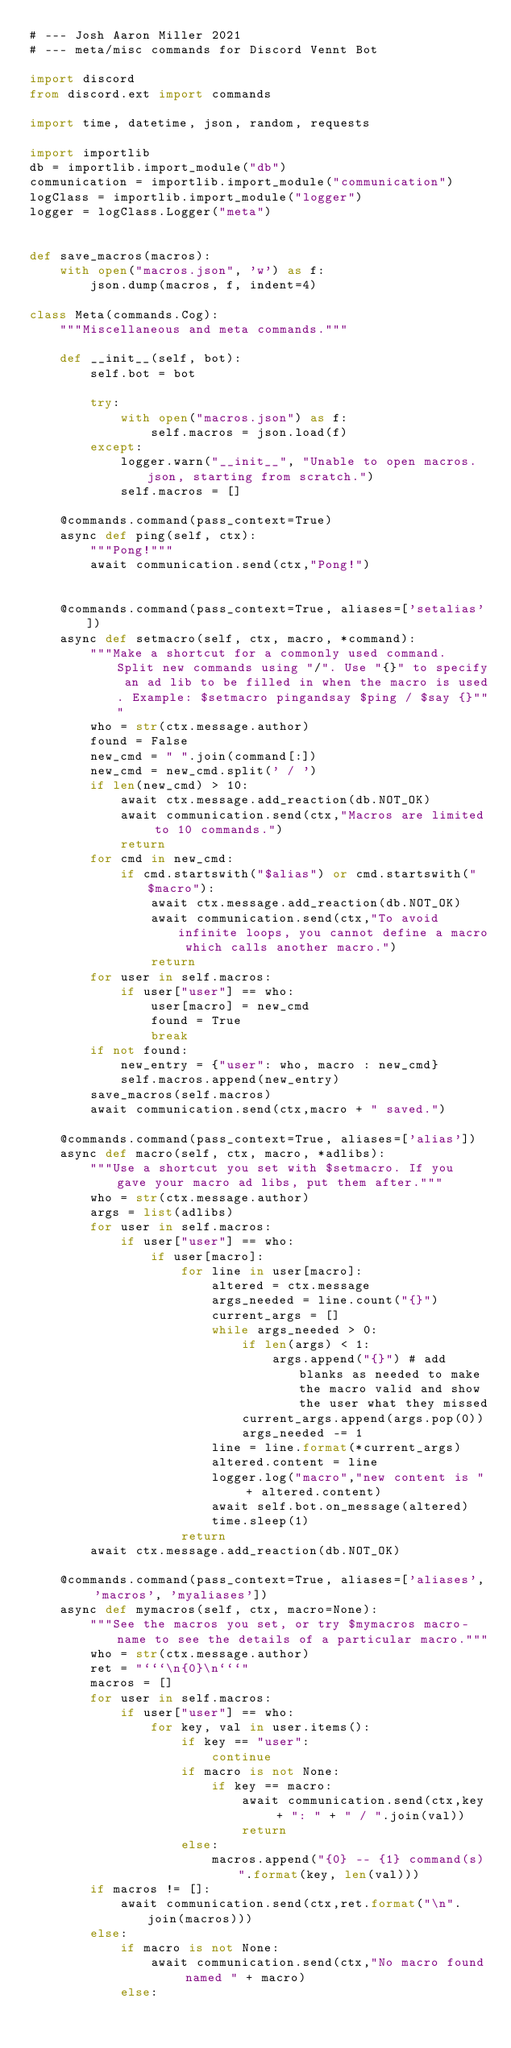Convert code to text. <code><loc_0><loc_0><loc_500><loc_500><_Python_># --- Josh Aaron Miller 2021
# --- meta/misc commands for Discord Vennt Bot

import discord
from discord.ext import commands

import time, datetime, json, random, requests

import importlib
db = importlib.import_module("db")
communication = importlib.import_module("communication")
logClass = importlib.import_module("logger")
logger = logClass.Logger("meta")

    
def save_macros(macros):
    with open("macros.json", 'w') as f:
        json.dump(macros, f, indent=4)
    
class Meta(commands.Cog):
    """Miscellaneous and meta commands."""

    def __init__(self, bot):
        self.bot = bot
           
        try:
            with open("macros.json") as f:
                self.macros = json.load(f)
        except:
            logger.warn("__init__", "Unable to open macros.json, starting from scratch.")
            self.macros = []

    @commands.command(pass_context=True)
    async def ping(self, ctx):
        """Pong!"""
        await communication.send(ctx,"Pong!")
    

    @commands.command(pass_context=True, aliases=['setalias'])
    async def setmacro(self, ctx, macro, *command):
        """Make a shortcut for a commonly used command. Split new commands using "/". Use "{}" to specify an ad lib to be filled in when the macro is used. Example: $setmacro pingandsay $ping / $say {}"""
        who = str(ctx.message.author)
        found = False
        new_cmd = " ".join(command[:])
        new_cmd = new_cmd.split(' / ')
        if len(new_cmd) > 10:
            await ctx.message.add_reaction(db.NOT_OK)
            await communication.send(ctx,"Macros are limited to 10 commands.")
            return
        for cmd in new_cmd:
            if cmd.startswith("$alias") or cmd.startswith("$macro"):
                await ctx.message.add_reaction(db.NOT_OK)
                await communication.send(ctx,"To avoid infinite loops, you cannot define a macro which calls another macro.")
                return
        for user in self.macros:
            if user["user"] == who:
                user[macro] = new_cmd
                found = True
                break
        if not found:
            new_entry = {"user": who, macro : new_cmd}
            self.macros.append(new_entry)
        save_macros(self.macros)
        await communication.send(ctx,macro + " saved.")
        
    @commands.command(pass_context=True, aliases=['alias'])
    async def macro(self, ctx, macro, *adlibs):
        """Use a shortcut you set with $setmacro. If you gave your macro ad libs, put them after."""
        who = str(ctx.message.author)
        args = list(adlibs)
        for user in self.macros:
            if user["user"] == who:
                if user[macro]:
                    for line in user[macro]:
                        altered = ctx.message
                        args_needed = line.count("{}")
                        current_args = []
                        while args_needed > 0:
                            if len(args) < 1:
                                args.append("{}") # add blanks as needed to make the macro valid and show the user what they missed
                            current_args.append(args.pop(0))
                            args_needed -= 1
                        line = line.format(*current_args)
                        altered.content = line
                        logger.log("macro","new content is " + altered.content)
                        await self.bot.on_message(altered)
                        time.sleep(1)
                    return
        await ctx.message.add_reaction(db.NOT_OK)
        
    @commands.command(pass_context=True, aliases=['aliases', 'macros', 'myaliases'])
    async def mymacros(self, ctx, macro=None):
        """See the macros you set, or try $mymacros macro-name to see the details of a particular macro."""
        who = str(ctx.message.author)
        ret = "```\n{0}\n```"
        macros = []
        for user in self.macros:
            if user["user"] == who:
                for key, val in user.items():
                    if key == "user":
                        continue
                    if macro is not None:
                        if key == macro:
                            await communication.send(ctx,key + ": " + " / ".join(val))
                            return
                    else:
                        macros.append("{0} -- {1} command(s)".format(key, len(val)))
        if macros != []:
            await communication.send(ctx,ret.format("\n".join(macros)))
        else:
            if macro is not None:
                await communication.send(ctx,"No macro found named " + macro)
            else:</code> 